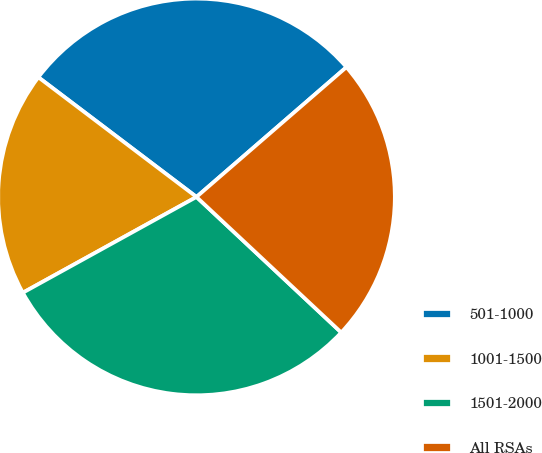<chart> <loc_0><loc_0><loc_500><loc_500><pie_chart><fcel>501-1000<fcel>1001-1500<fcel>1501-2000<fcel>All RSAs<nl><fcel>28.33%<fcel>18.33%<fcel>30.0%<fcel>23.33%<nl></chart> 